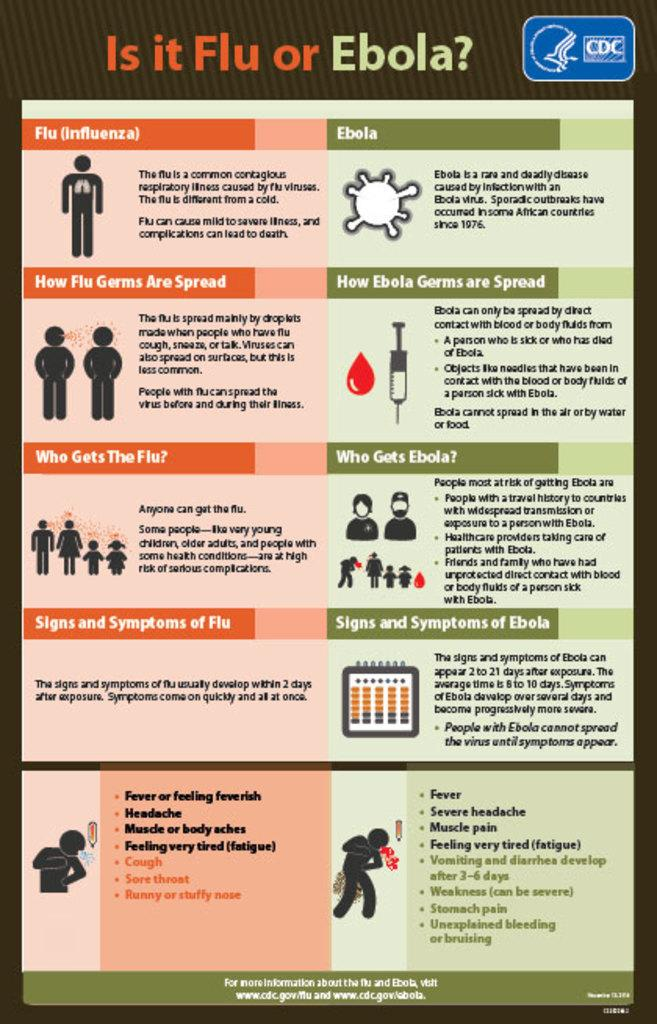<image>
Describe the image concisely. The poster from the CDC gives guidance on whether someone is suffering from the flu or ebola. 